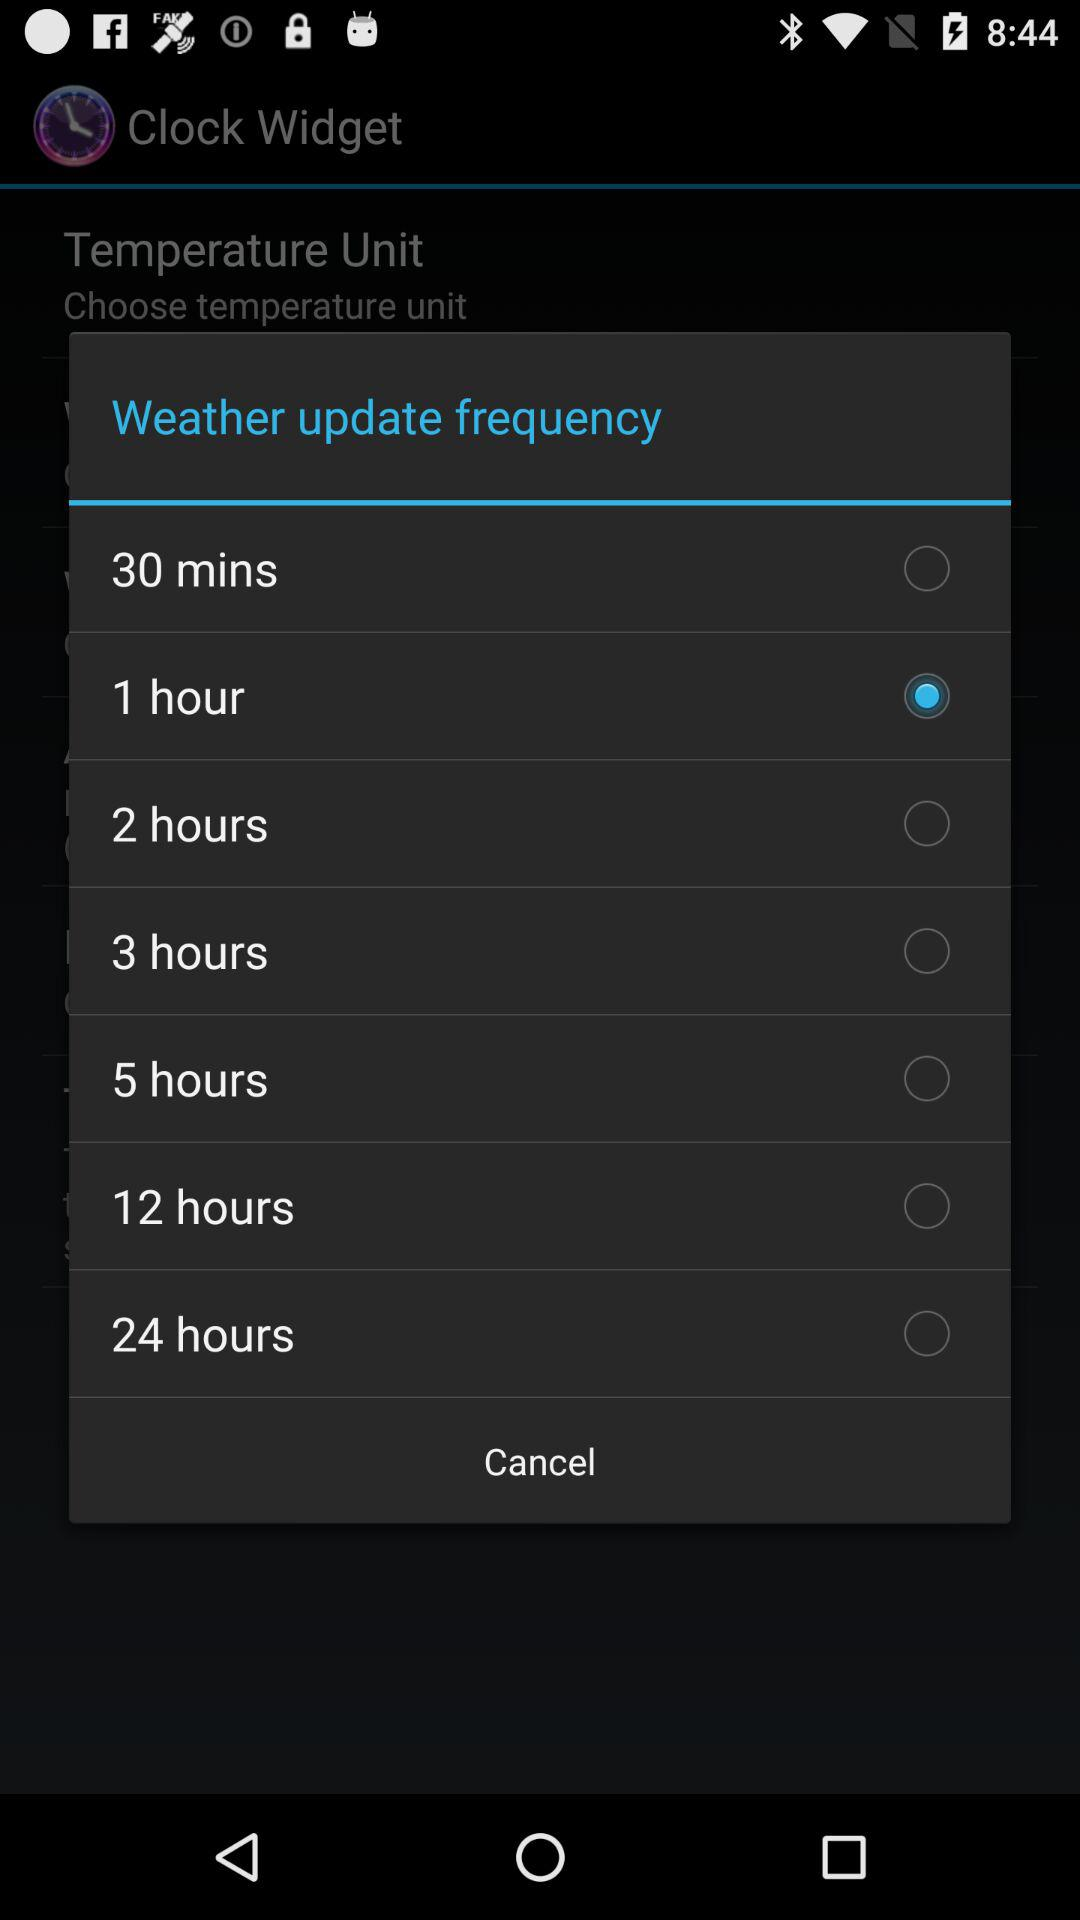Which option has been selected in "Weather update frequency"? The selected option is "1 hour". 